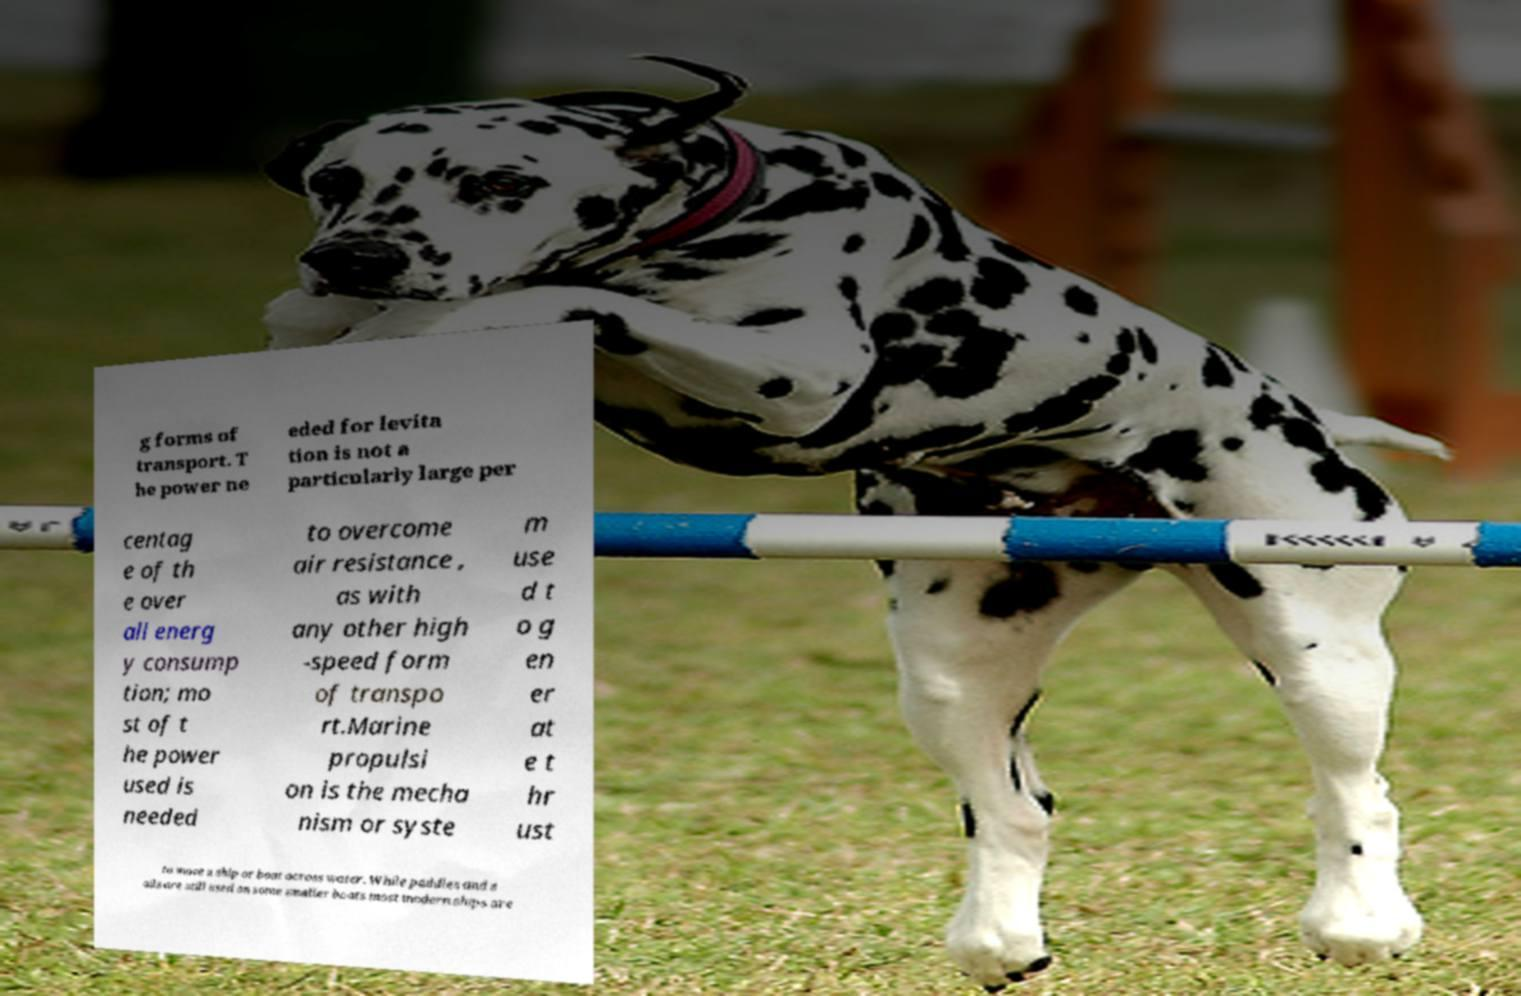Could you assist in decoding the text presented in this image and type it out clearly? g forms of transport. T he power ne eded for levita tion is not a particularly large per centag e of th e over all energ y consump tion; mo st of t he power used is needed to overcome air resistance , as with any other high -speed form of transpo rt.Marine propulsi on is the mecha nism or syste m use d t o g en er at e t hr ust to move a ship or boat across water. While paddles and s ails are still used on some smaller boats most modern ships are 